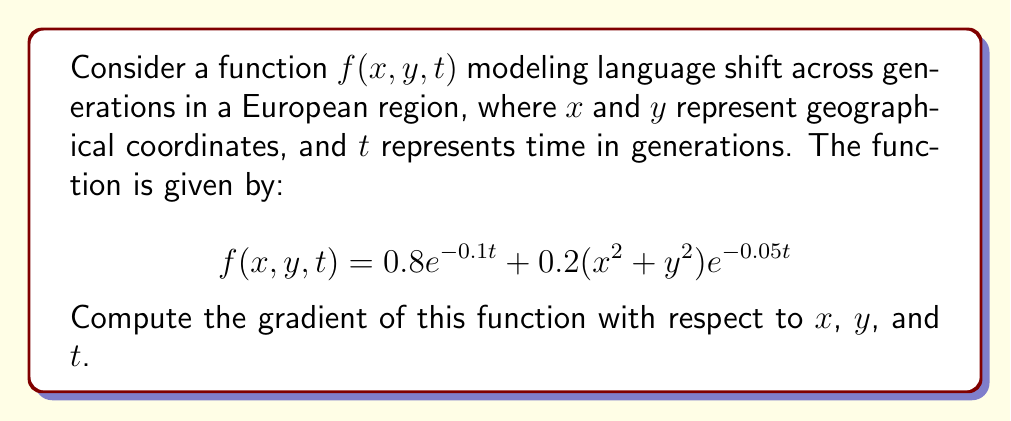Give your solution to this math problem. To compute the gradient of the function $f(x, y, t)$, we need to calculate the partial derivatives with respect to each variable:

1. Partial derivative with respect to $x$:
   $$\frac{\partial f}{\partial x} = \frac{\partial}{\partial x}[0.8e^{-0.1t} + 0.2(x^2 + y^2)e^{-0.05t}]$$
   $$= 0 + 0.2(2x)e^{-0.05t} = 0.4xe^{-0.05t}$$

2. Partial derivative with respect to $y$:
   $$\frac{\partial f}{\partial y} = \frac{\partial}{\partial y}[0.8e^{-0.1t} + 0.2(x^2 + y^2)e^{-0.05t}]$$
   $$= 0 + 0.2(2y)e^{-0.05t} = 0.4ye^{-0.05t}$$

3. Partial derivative with respect to $t$:
   $$\frac{\partial f}{\partial t} = \frac{\partial}{\partial t}[0.8e^{-0.1t} + 0.2(x^2 + y^2)e^{-0.05t}]$$
   $$= 0.8(-0.1)e^{-0.1t} + 0.2(x^2 + y^2)(-0.05)e^{-0.05t}$$
   $$= -0.08e^{-0.1t} - 0.01(x^2 + y^2)e^{-0.05t}$$

The gradient is a vector of these partial derivatives:

$$\nabla f(x, y, t) = \left(\frac{\partial f}{\partial x}, \frac{\partial f}{\partial y}, \frac{\partial f}{\partial t}\right)$$

Substituting the calculated partial derivatives:

$$\nabla f(x, y, t) = (0.4xe^{-0.05t}, 0.4ye^{-0.05t}, -0.08e^{-0.1t} - 0.01(x^2 + y^2)e^{-0.05t})$$
Answer: $(0.4xe^{-0.05t}, 0.4ye^{-0.05t}, -0.08e^{-0.1t} - 0.01(x^2 + y^2)e^{-0.05t})$ 